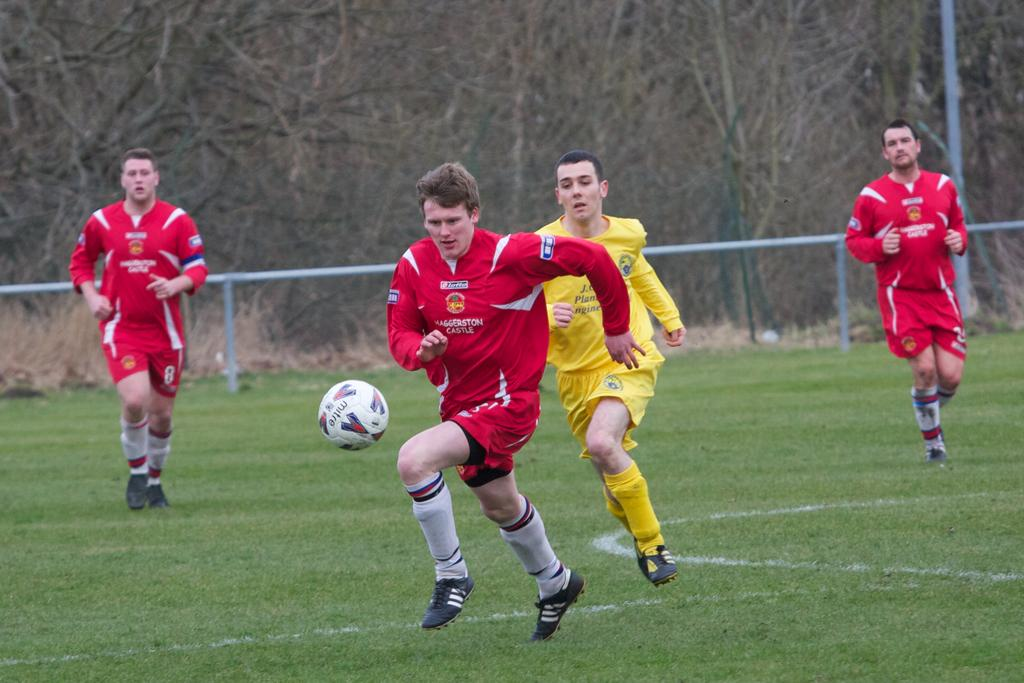How many people are present in the image? There are four people in the image. What are the people doing in the image? The people are running on the grass and playing a game. Can you describe the object in the air? There is a ball in the air. What can be seen in the background of the image? There are rods, a pole, trees, and plants in the background of the image. What type of grip does the hall have in the image? There is no hall present in the image, so it is not possible to determine the type of grip it might have. 